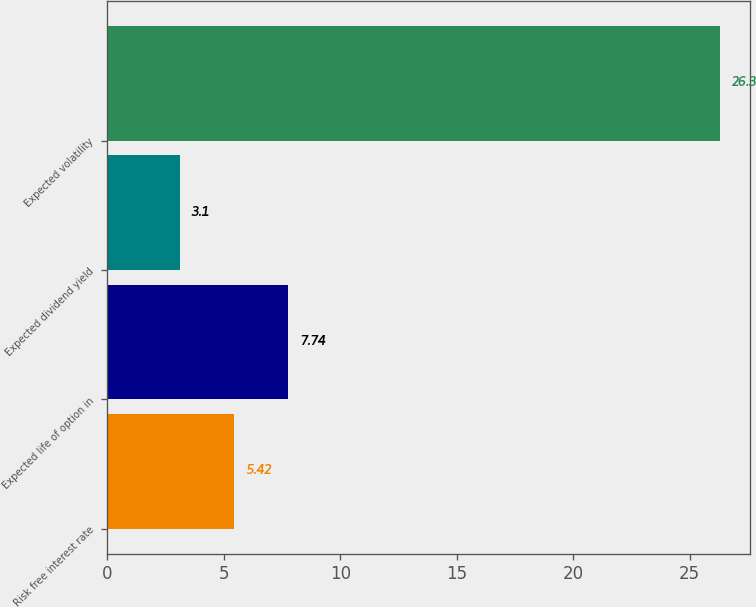Convert chart. <chart><loc_0><loc_0><loc_500><loc_500><bar_chart><fcel>Risk free interest rate<fcel>Expected life of option in<fcel>Expected dividend yield<fcel>Expected volatility<nl><fcel>5.42<fcel>7.74<fcel>3.1<fcel>26.3<nl></chart> 